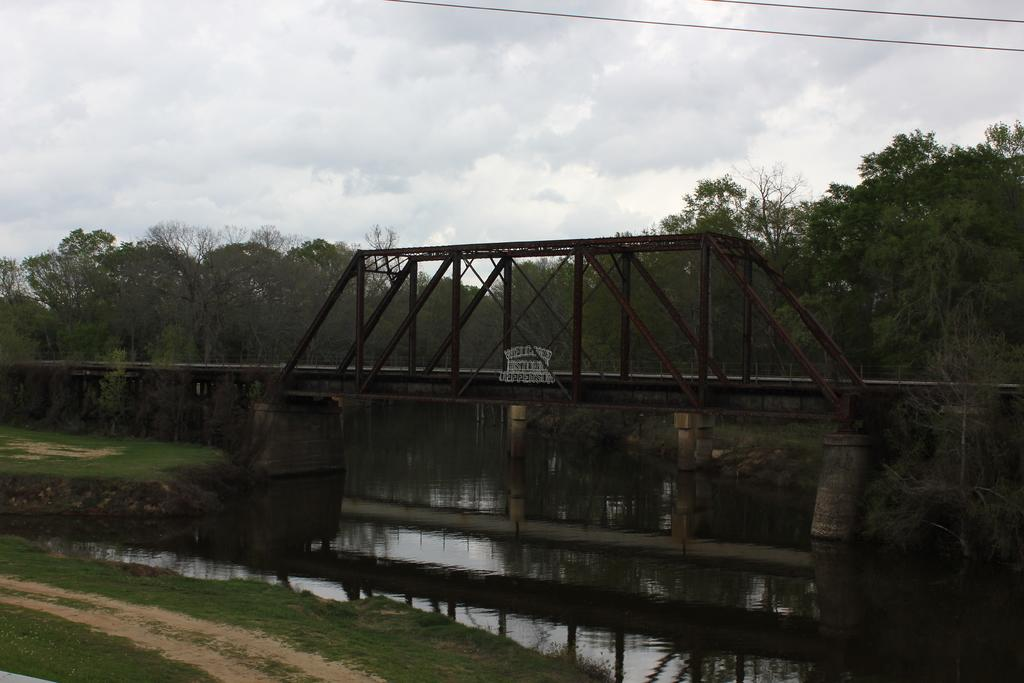What type of natural feature is present in the image? There is a river in the image. What structure is built over the river? There is a bridge above the river. What can be seen in the background of the image? There are trees and the sky visible in the background of the image. What type of insurance is required to drive across the bridge in the image? There is no mention of driving or vehicles in the image, so it is not possible to determine the type of insurance required. 